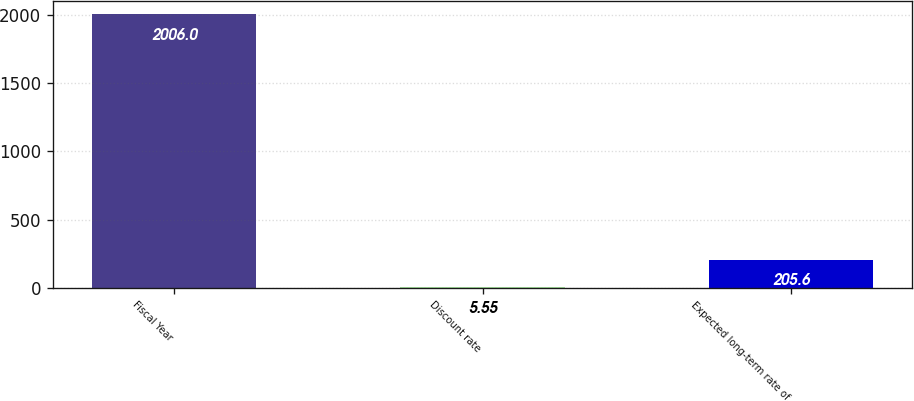Convert chart. <chart><loc_0><loc_0><loc_500><loc_500><bar_chart><fcel>Fiscal Year<fcel>Discount rate<fcel>Expected long-term rate of<nl><fcel>2006<fcel>5.55<fcel>205.6<nl></chart> 